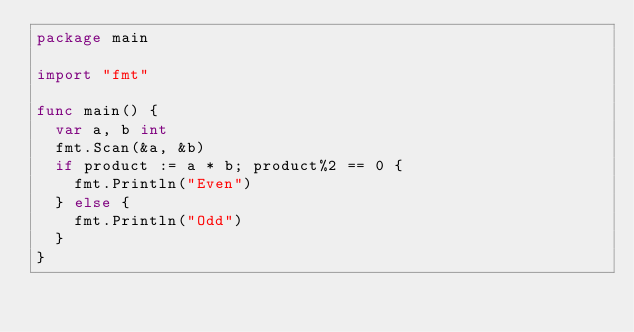Convert code to text. <code><loc_0><loc_0><loc_500><loc_500><_Go_>package main

import "fmt"

func main() {
	var a, b int
	fmt.Scan(&a, &b)
	if product := a * b; product%2 == 0 {
		fmt.Println("Even")
	} else {
		fmt.Println("Odd")
	}
}
</code> 